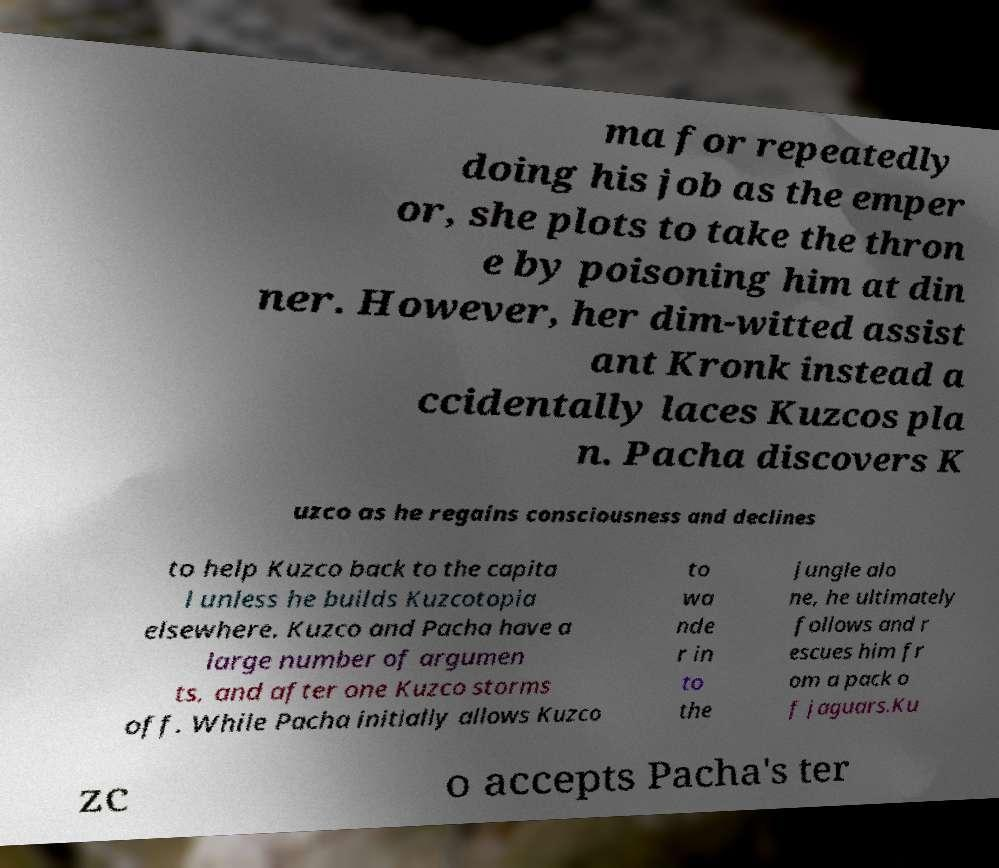I need the written content from this picture converted into text. Can you do that? ma for repeatedly doing his job as the emper or, she plots to take the thron e by poisoning him at din ner. However, her dim-witted assist ant Kronk instead a ccidentally laces Kuzcos pla n. Pacha discovers K uzco as he regains consciousness and declines to help Kuzco back to the capita l unless he builds Kuzcotopia elsewhere. Kuzco and Pacha have a large number of argumen ts, and after one Kuzco storms off. While Pacha initially allows Kuzco to wa nde r in to the jungle alo ne, he ultimately follows and r escues him fr om a pack o f jaguars.Ku zc o accepts Pacha's ter 